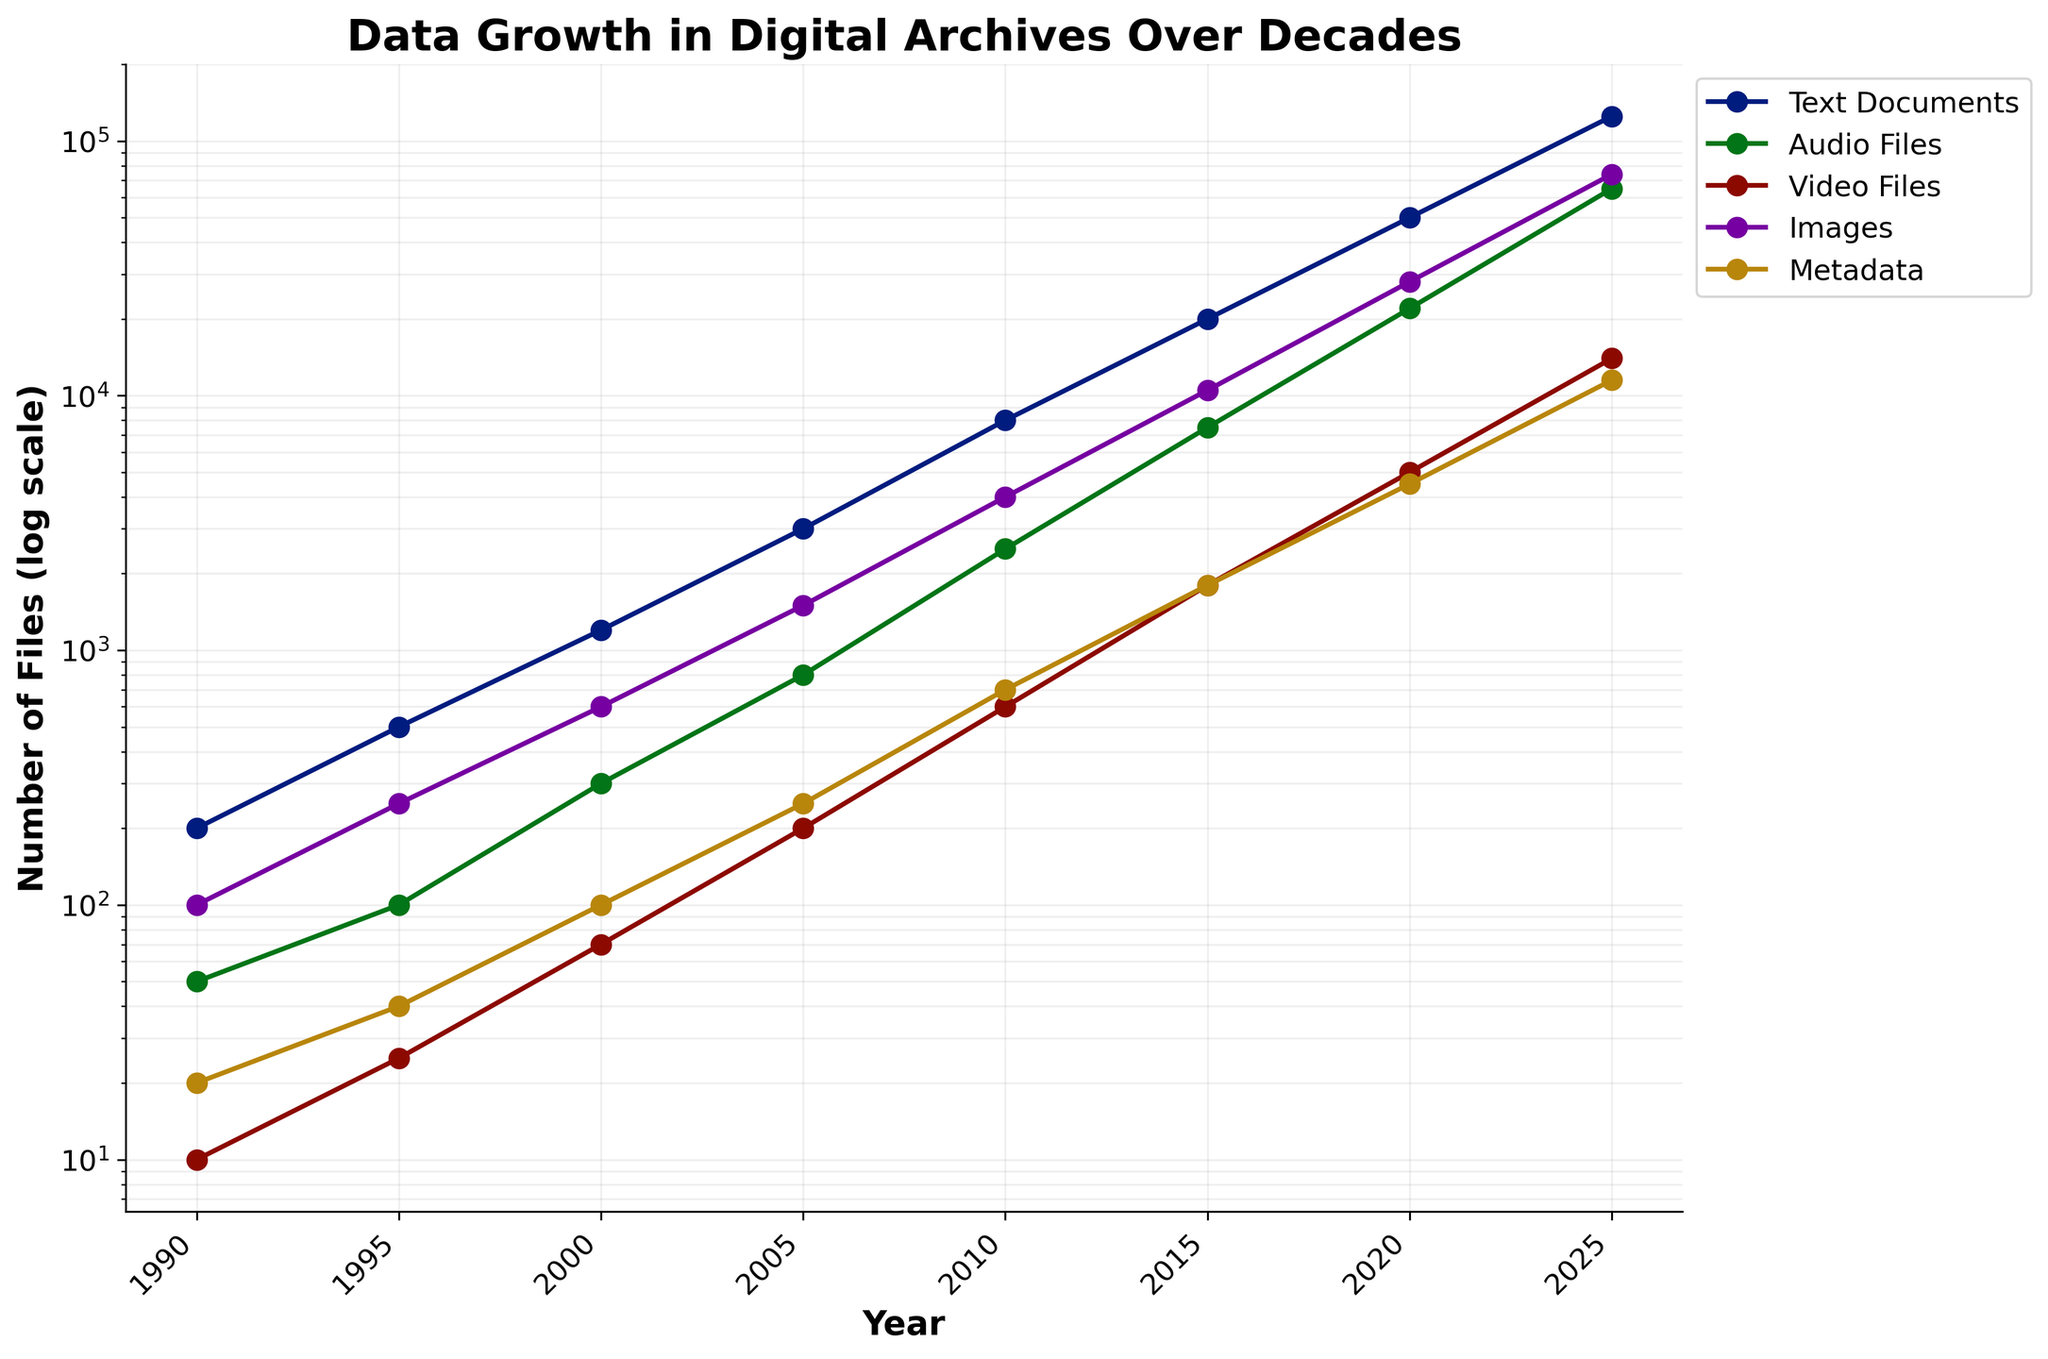What is the general trend of data growth in digital archives over the decades? The plot shows an upward trajectory for all file types. This indicates a consistent increase in the number of files stored in digital archives over the years.
Answer: Increasing What is the title of the plot? The title is prominently displayed at the top of the plot. It describes the overall theme of the figure.
Answer: Data Growth in Digital Archives Over Decades Which file type reached the highest number of files by 2025? By observing the end points of the lines in the plot at 2025, we can see that Text Documents have the highest count.
Answer: Text Documents By how much did the number of Audio Files increase from 1990 to 2020? Referring to the y-values of the Audio Files line at 1990 (50) and 2020 (22000), we calculate the difference: 22000 - 50 = 21950.
Answer: 21950 Which two file types show the closest number of files around the year 2000? By examining the lines around the year 2000, we note that Images and Metadata have close values. Images have 600 files, Metadata have 100 files; these are the closest relative to other file types.
Answer: Images and Metadata How does the growth rate of Video Files compare to that of Images from 2005 to 2025? By comparing the slopes of the Video Files and Images lines between 2005 and 2025, it can be seen that both lines increase, but the Images line has a steeper slope, indicating a higher growth rate.
Answer: Images grow faster Describe any significant changes in the number of Metadata files from 2010 to 2015. From 2010 (700 files) to 2015 (1800 files), the number of Metadata files increased significantly, more than doubling in this period.
Answer: More than doubled What type of scale is used on the y-axis? The y-axis uses a log scale to accommodate the wide range of data values, showing exponential growth more clearly.
Answer: Logarithmic scale In which period do Text Documents see the largest increase in the number? Comparing the differences between consecutive points on the Text Documents line, the period from 2020 to 2025 shows the largest increase (from 50000 to 125000).
Answer: 2020-2025 From the years provided, which year does Images have the lowest number of files stored? By looking at the initial point of the Images line, it is evident that 1990 has the lowest number (100 files).
Answer: 1990 